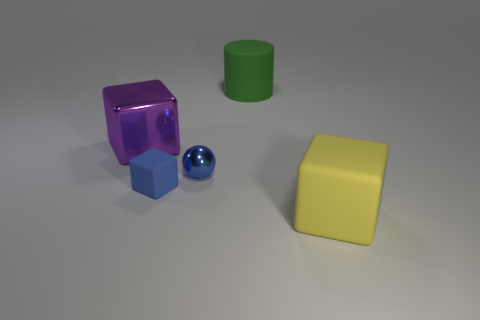There is a small metallic thing; is its color the same as the matte object that is left of the big cylinder?
Offer a very short reply. Yes. What is the size of the blue thing that is the same shape as the purple metallic object?
Provide a succinct answer. Small. What number of blocks are large gray shiny things or yellow rubber objects?
Provide a succinct answer. 1. What is the material of the tiny object that is the same color as the small ball?
Your response must be concise. Rubber. Are there fewer metal blocks in front of the large purple shiny thing than tiny rubber objects on the left side of the large yellow cube?
Make the answer very short. Yes. How many objects are either cubes that are left of the large yellow block or big yellow blocks?
Your response must be concise. 3. What shape is the blue thing that is right of the rubber object that is left of the tiny metal object?
Provide a short and direct response. Sphere. Are there any objects that have the same size as the blue matte cube?
Keep it short and to the point. Yes. Are there more large yellow blocks than metallic objects?
Your answer should be very brief. No. There is a rubber cube that is behind the yellow rubber thing; is its size the same as the rubber cube that is in front of the small blue matte thing?
Keep it short and to the point. No. 